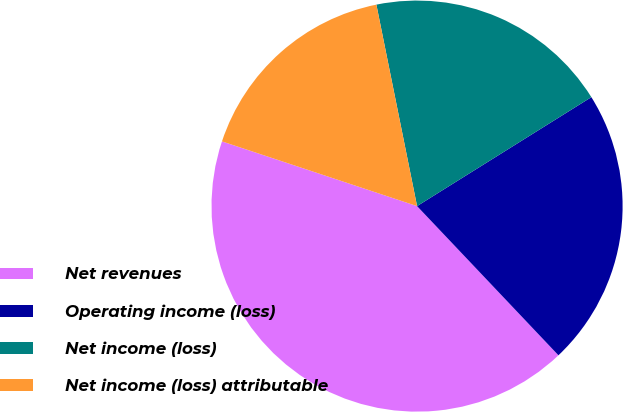Convert chart to OTSL. <chart><loc_0><loc_0><loc_500><loc_500><pie_chart><fcel>Net revenues<fcel>Operating income (loss)<fcel>Net income (loss)<fcel>Net income (loss) attributable<nl><fcel>42.17%<fcel>21.82%<fcel>19.28%<fcel>16.73%<nl></chart> 